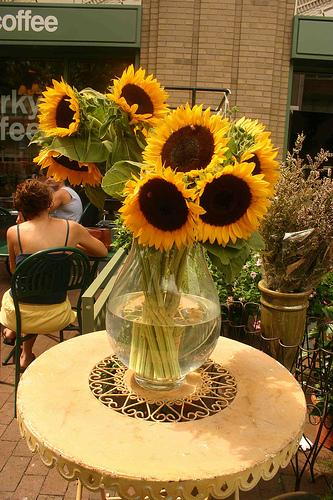Construct a brief sentence describing the main character, its actions, and its personal appearance within the image. A delightful bouquet of sunflowers sits perched in a see-through vase atop a metal table, surrounded by busy townsfolk and street life. Illustrate the primary scene of the image and its components using imaginative language. Golden sunflower heads, cradled lovingly by a crystal vase, capture the very essence of life itself, as the tableau of the bustling street unfolds around them, complete with its cast of characters. Give a brief yet detailed description of the highlighted object and the ongoing activity in the image. A sumptuous cluster of sunflowers sit proudly in a transparent vase upon a metal table, as onlookers and passersby add to the atmosphere of the lively scene. List the primary object and occurrences in the image. Sunflowers in a clear vase, metal table, people sitting, green sign above shop, woman in yellow skirt, man in blue shirt. Please provide a concise description of the primary object displayed in the image and what action is occurring. A large sunflower bouquet is placed in a clear vase on a metal table, with people sitting nearby and a green sign above a shop in the background. Narrate the primary focus of the image and the surrounding environment in the style of a story. Once upon a time, sunflowers in a transparent vase stood tall on a metal table, as people gathered around, sharing stories and laughter under the watchful gaze of a green sign. Using vivid and descriptive language, portray the main scenario occurring within the image. In a lively town square, a splendid bouquet of sunflowers dazzle, resting gracefully in a shining glass vessel, surrounded by people illustrating the rich tapestry of life. In the style of a news headline, summarize the central subject and associated action in the image. Sunflower Spectacle Graces Bustling Street Scene, Captivating Locals and Passersby Alike. Summarize the core subject and situation in the image using creative language. Amidst the cacophony of life, radiant sunflowers hold court, at home in their gleaming crystal chalice, standing witness to the everyday magic of the bustling world. In a poetic manner, describe the central theme and activity of the image. Sunflowers, vibrant and grand, rest in a glass vase, amidst the soft hum of bystanders; a tableau of life unfolds on this busy street. 